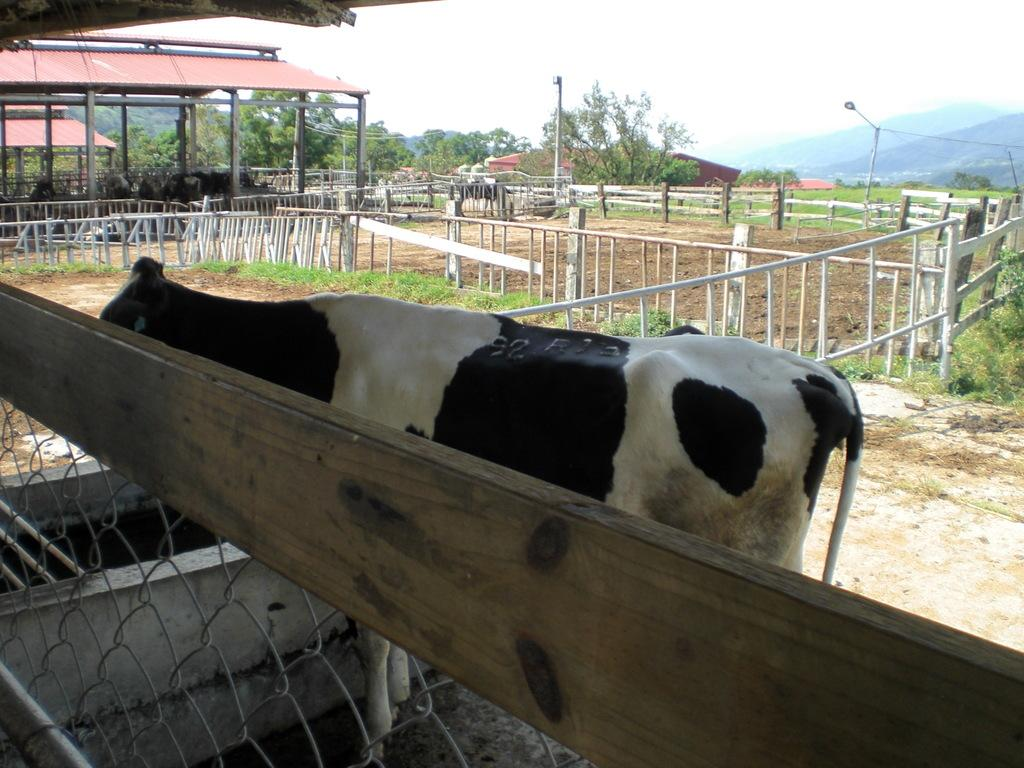What animal is present in the image? There is a cow in the image. Where is the cow located? The cow is in a farm. What type of barrier can be seen in the image? There is fencing in the image. What type of vegetation is present in the image? There are trees and plants in the image. What type of structures can be seen in the image? There are poles in the image. What natural feature is visible in the background of the image? There are mountains visible in the image. What type of ear is the cow wearing in the image? The cow is not wearing any ear in the image. What does the cow need to do in the image? The image does not depict any specific action or need for the cow. 